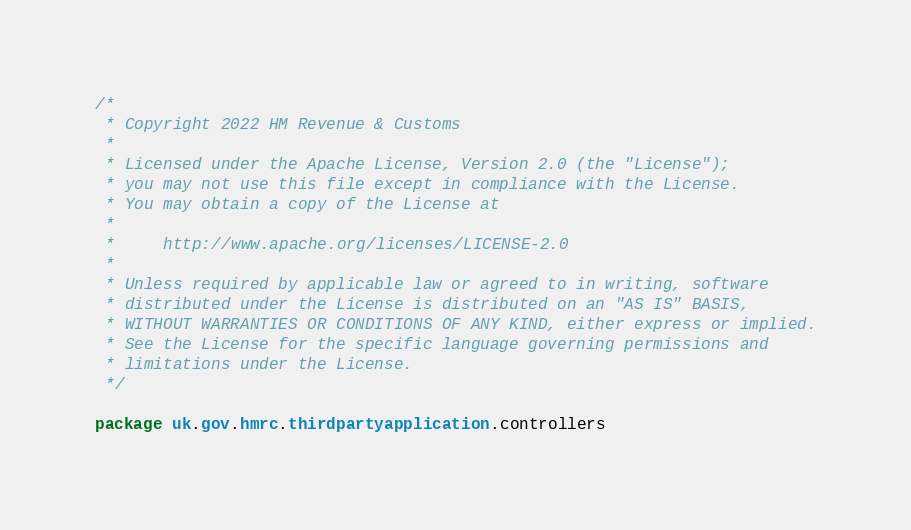Convert code to text. <code><loc_0><loc_0><loc_500><loc_500><_Scala_>/*
 * Copyright 2022 HM Revenue & Customs
 *
 * Licensed under the Apache License, Version 2.0 (the "License");
 * you may not use this file except in compliance with the License.
 * You may obtain a copy of the License at
 *
 *     http://www.apache.org/licenses/LICENSE-2.0
 *
 * Unless required by applicable law or agreed to in writing, software
 * distributed under the License is distributed on an "AS IS" BASIS,
 * WITHOUT WARRANTIES OR CONDITIONS OF ANY KIND, either express or implied.
 * See the License for the specific language governing permissions and
 * limitations under the License.
 */

package uk.gov.hmrc.thirdpartyapplication.controllers
</code> 